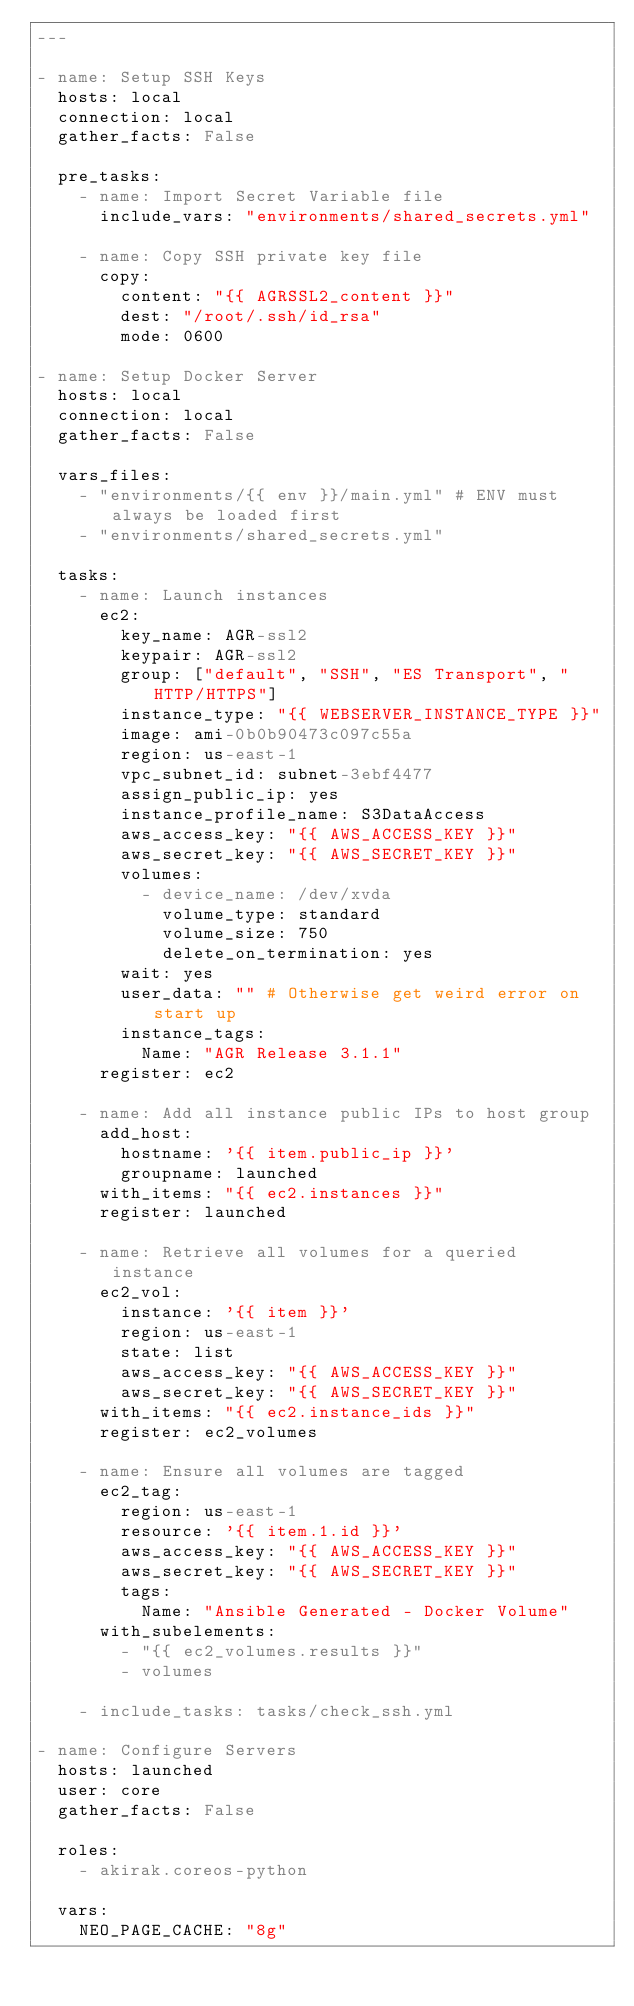Convert code to text. <code><loc_0><loc_0><loc_500><loc_500><_YAML_>---

- name: Setup SSH Keys
  hosts: local
  connection: local
  gather_facts: False

  pre_tasks:
    - name: Import Secret Variable file
      include_vars: "environments/shared_secrets.yml"
    
    - name: Copy SSH private key file
      copy:
        content: "{{ AGRSSL2_content }}"
        dest: "/root/.ssh/id_rsa"
        mode: 0600

- name: Setup Docker Server
  hosts: local
  connection: local
  gather_facts: False

  vars_files:
    - "environments/{{ env }}/main.yml" # ENV must always be loaded first
    - "environments/shared_secrets.yml"

  tasks:
    - name: Launch instances
      ec2:
        key_name: AGR-ssl2
        keypair: AGR-ssl2
        group: ["default", "SSH", "ES Transport", "HTTP/HTTPS"]
        instance_type: "{{ WEBSERVER_INSTANCE_TYPE }}"
        image: ami-0b0b90473c097c55a
        region: us-east-1
        vpc_subnet_id: subnet-3ebf4477
        assign_public_ip: yes
        instance_profile_name: S3DataAccess
        aws_access_key: "{{ AWS_ACCESS_KEY }}"
        aws_secret_key: "{{ AWS_SECRET_KEY }}"
        volumes:
          - device_name: /dev/xvda
            volume_type: standard
            volume_size: 750
            delete_on_termination: yes
        wait: yes
        user_data: "" # Otherwise get weird error on start up
        instance_tags:
          Name: "AGR Release 3.1.1"
      register: ec2

    - name: Add all instance public IPs to host group
      add_host:
        hostname: '{{ item.public_ip }}'
        groupname: launched
      with_items: "{{ ec2.instances }}"
      register: launched

    - name: Retrieve all volumes for a queried instance
      ec2_vol:
        instance: '{{ item }}'
        region: us-east-1
        state: list
        aws_access_key: "{{ AWS_ACCESS_KEY }}"
        aws_secret_key: "{{ AWS_SECRET_KEY }}"
      with_items: "{{ ec2.instance_ids }}"
      register: ec2_volumes

    - name: Ensure all volumes are tagged
      ec2_tag:
        region: us-east-1
        resource: '{{ item.1.id }}'
        aws_access_key: "{{ AWS_ACCESS_KEY }}"
        aws_secret_key: "{{ AWS_SECRET_KEY }}"
        tags:
          Name: "Ansible Generated - Docker Volume"
      with_subelements:
        - "{{ ec2_volumes.results }}"
        - volumes

    - include_tasks: tasks/check_ssh.yml

- name: Configure Servers
  hosts: launched
  user: core
  gather_facts: False

  roles:
    - akirak.coreos-python

  vars:
    NEO_PAGE_CACHE: "8g"</code> 